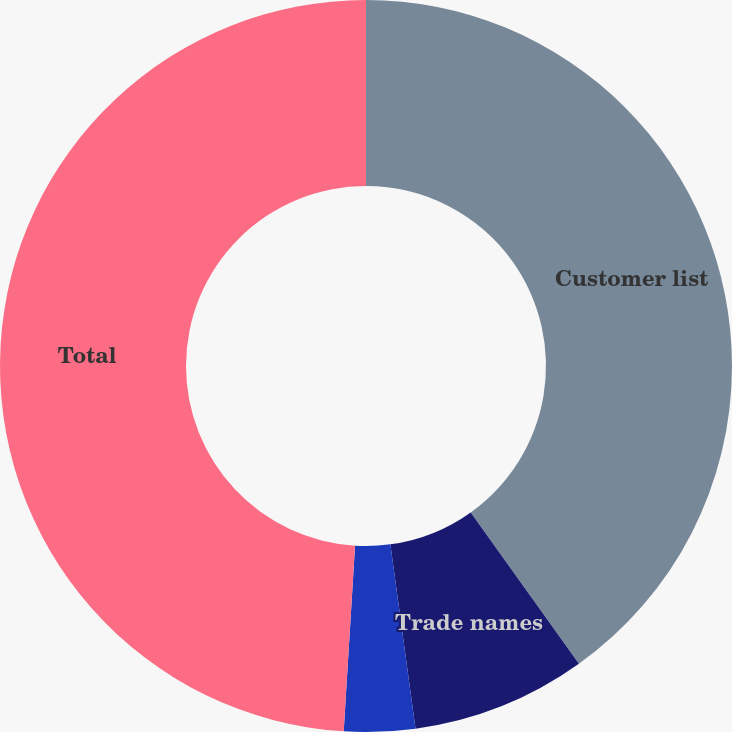Convert chart to OTSL. <chart><loc_0><loc_0><loc_500><loc_500><pie_chart><fcel>Customer list<fcel>Trade names<fcel>Other<fcel>Total<nl><fcel>40.12%<fcel>7.72%<fcel>3.13%<fcel>49.03%<nl></chart> 